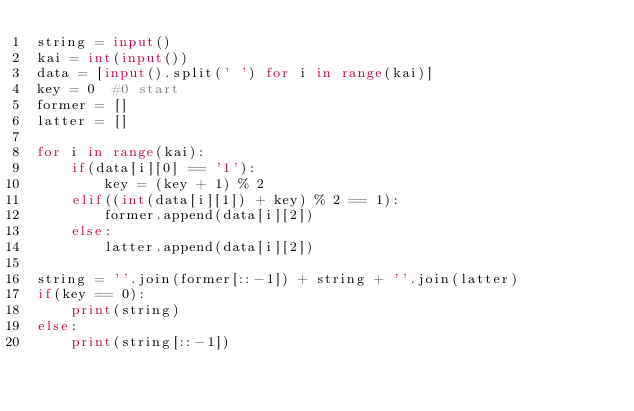Convert code to text. <code><loc_0><loc_0><loc_500><loc_500><_Python_>string = input()
kai = int(input())
data = [input().split(' ') for i in range(kai)]
key = 0  #0 start
former = []
latter = []

for i in range(kai):
    if(data[i][0] == '1'):
        key = (key + 1) % 2
    elif((int(data[i][1]) + key) % 2 == 1):
        former.append(data[i][2])
    else:
        latter.append(data[i][2])

string = ''.join(former[::-1]) + string + ''.join(latter)
if(key == 0):
    print(string)
else:
    print(string[::-1])
</code> 